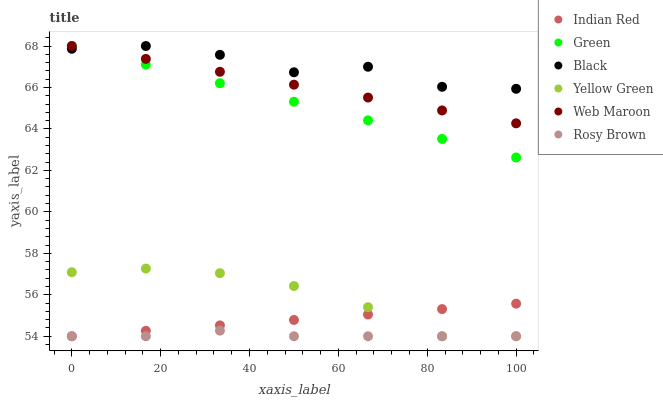Does Rosy Brown have the minimum area under the curve?
Answer yes or no. Yes. Does Black have the maximum area under the curve?
Answer yes or no. Yes. Does Web Maroon have the minimum area under the curve?
Answer yes or no. No. Does Web Maroon have the maximum area under the curve?
Answer yes or no. No. Is Web Maroon the smoothest?
Answer yes or no. Yes. Is Black the roughest?
Answer yes or no. Yes. Is Rosy Brown the smoothest?
Answer yes or no. No. Is Rosy Brown the roughest?
Answer yes or no. No. Does Yellow Green have the lowest value?
Answer yes or no. Yes. Does Web Maroon have the lowest value?
Answer yes or no. No. Does Green have the highest value?
Answer yes or no. Yes. Does Rosy Brown have the highest value?
Answer yes or no. No. Is Indian Red less than Web Maroon?
Answer yes or no. Yes. Is Web Maroon greater than Rosy Brown?
Answer yes or no. Yes. Does Yellow Green intersect Indian Red?
Answer yes or no. Yes. Is Yellow Green less than Indian Red?
Answer yes or no. No. Is Yellow Green greater than Indian Red?
Answer yes or no. No. Does Indian Red intersect Web Maroon?
Answer yes or no. No. 